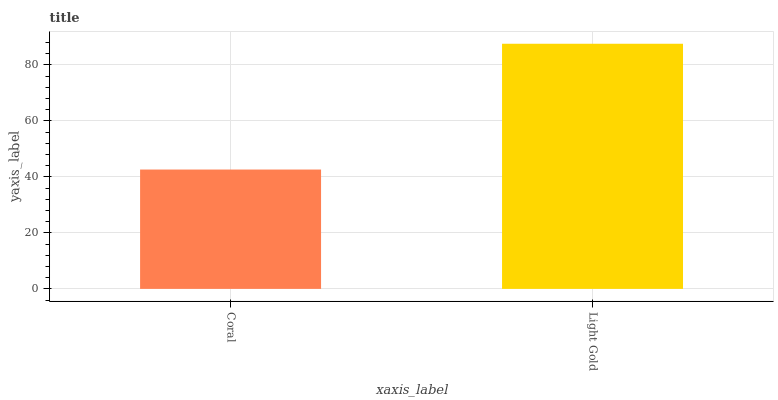Is Light Gold the minimum?
Answer yes or no. No. Is Light Gold greater than Coral?
Answer yes or no. Yes. Is Coral less than Light Gold?
Answer yes or no. Yes. Is Coral greater than Light Gold?
Answer yes or no. No. Is Light Gold less than Coral?
Answer yes or no. No. Is Light Gold the high median?
Answer yes or no. Yes. Is Coral the low median?
Answer yes or no. Yes. Is Coral the high median?
Answer yes or no. No. Is Light Gold the low median?
Answer yes or no. No. 